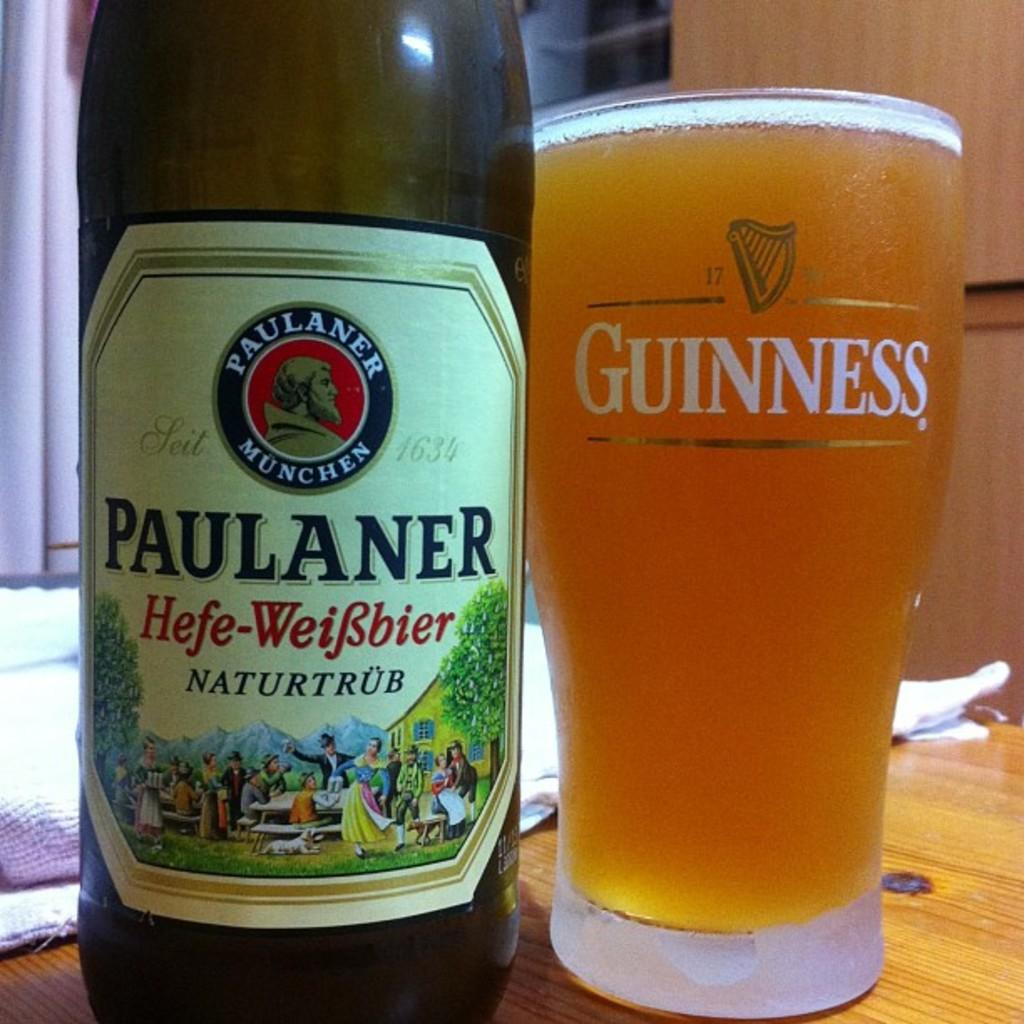<image>
Give a short and clear explanation of the subsequent image. A glass of guinness next to a beer bottle of Paulaner. 